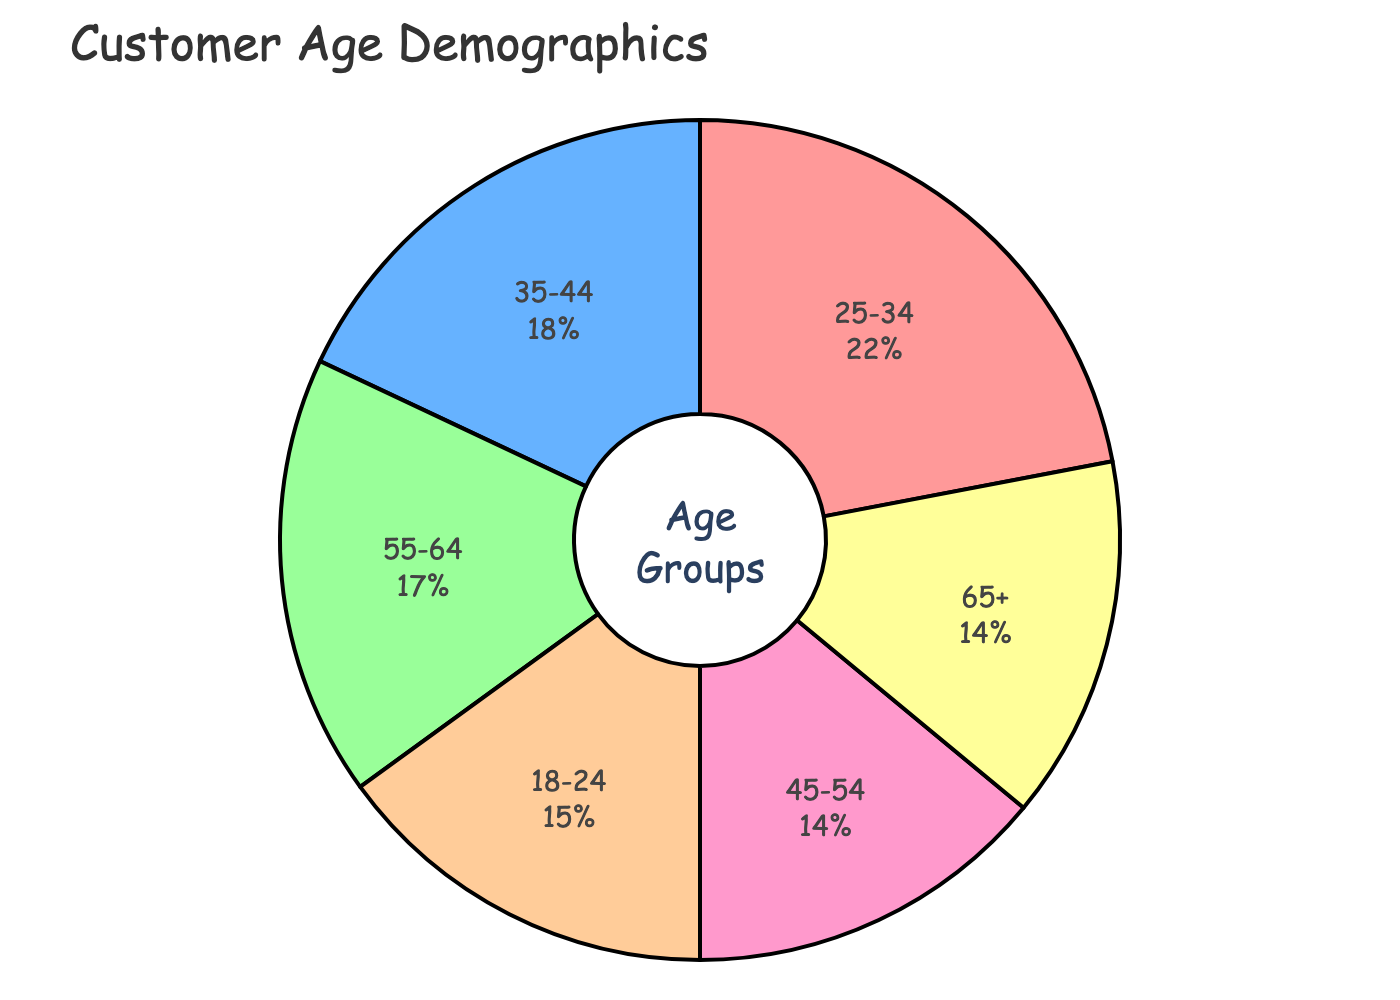What age group has the highest percentage of customers? The age group with the highest percentage is the one that occupies the largest portion of the pie chart.
Answer: 25-34 Which two age groups have an equal percentage of customers? To find equal percentages, visually check the pie chart for segments occupying the same amount of space and verify the percentage labels. Both 45-54 and 65+ have 14%.
Answer: 45-54 and 65+ What is the combined percentage of customers aged 55 and older? Add the percentages of the 55-64 and 65+ age groups: 17% + 14% = 31%.
Answer: 31% How does the percentage of customers aged 35-44 compare to those aged 25-34? Compare the numerical values directly: 18% for 35-44 and 22% for 25-34. The 25-34 percentage is higher.
Answer: 25-34 is higher Which age group has the second-highest percentage of customers? Identify the largest percentage first (25-34 at 22%), then find the next largest segment, which is 35-44 at 18%.
Answer: 35-44 What is the difference in percentage between the youngest and oldest age groups? Subtract the percentage of the 65+ group from the 18-24 group: 15% - 14% = 1%.
Answer: 1% Which age group is represented by the green color in the chart? Visually find the green segment on the chart and check the label for its age group.
Answer: 35-44 What is the average percentage of customers in the age groups under 35? Calculate the average by adding the percentages of 18-24 and 25-34 and dividing by 2: (15% + 22%) / 2 = 18.5%.
Answer: 18.5% How much more prevalent are customers aged 25-34 compared to those aged 45-54? Subtract the percentage of the 45-54 group from the 25-34 group: 22% - 14% = 8%.
Answer: 8% 